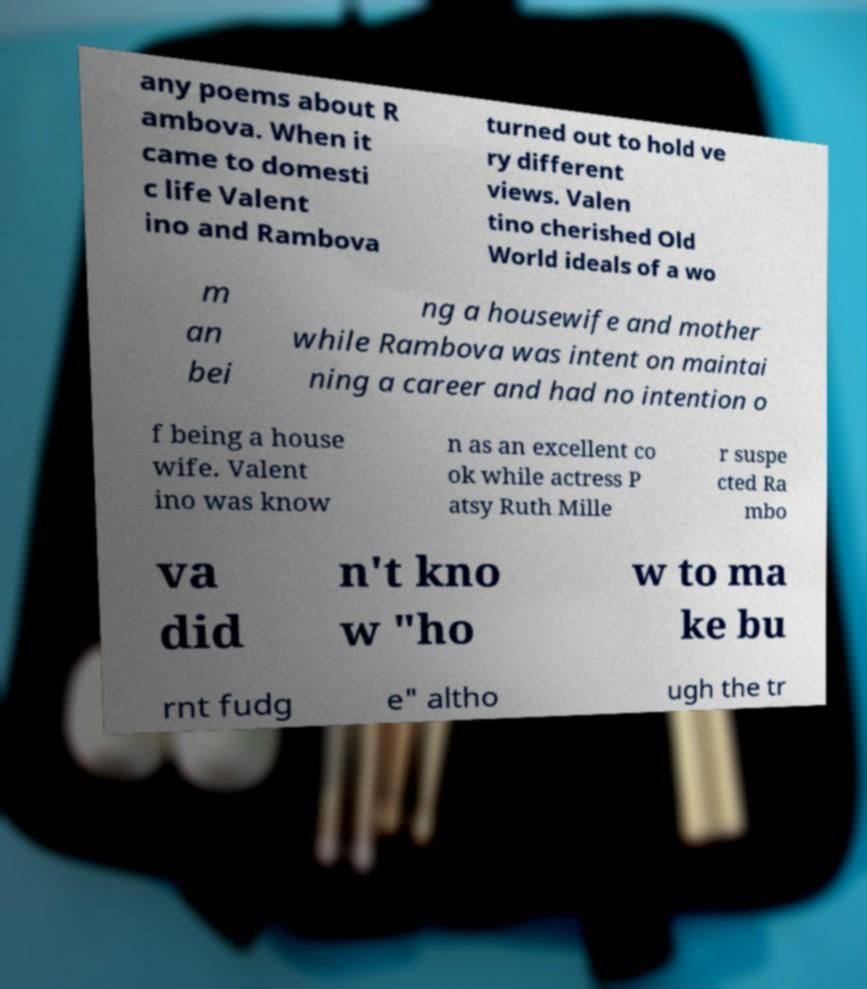Could you assist in decoding the text presented in this image and type it out clearly? any poems about R ambova. When it came to domesti c life Valent ino and Rambova turned out to hold ve ry different views. Valen tino cherished Old World ideals of a wo m an bei ng a housewife and mother while Rambova was intent on maintai ning a career and had no intention o f being a house wife. Valent ino was know n as an excellent co ok while actress P atsy Ruth Mille r suspe cted Ra mbo va did n't kno w "ho w to ma ke bu rnt fudg e" altho ugh the tr 